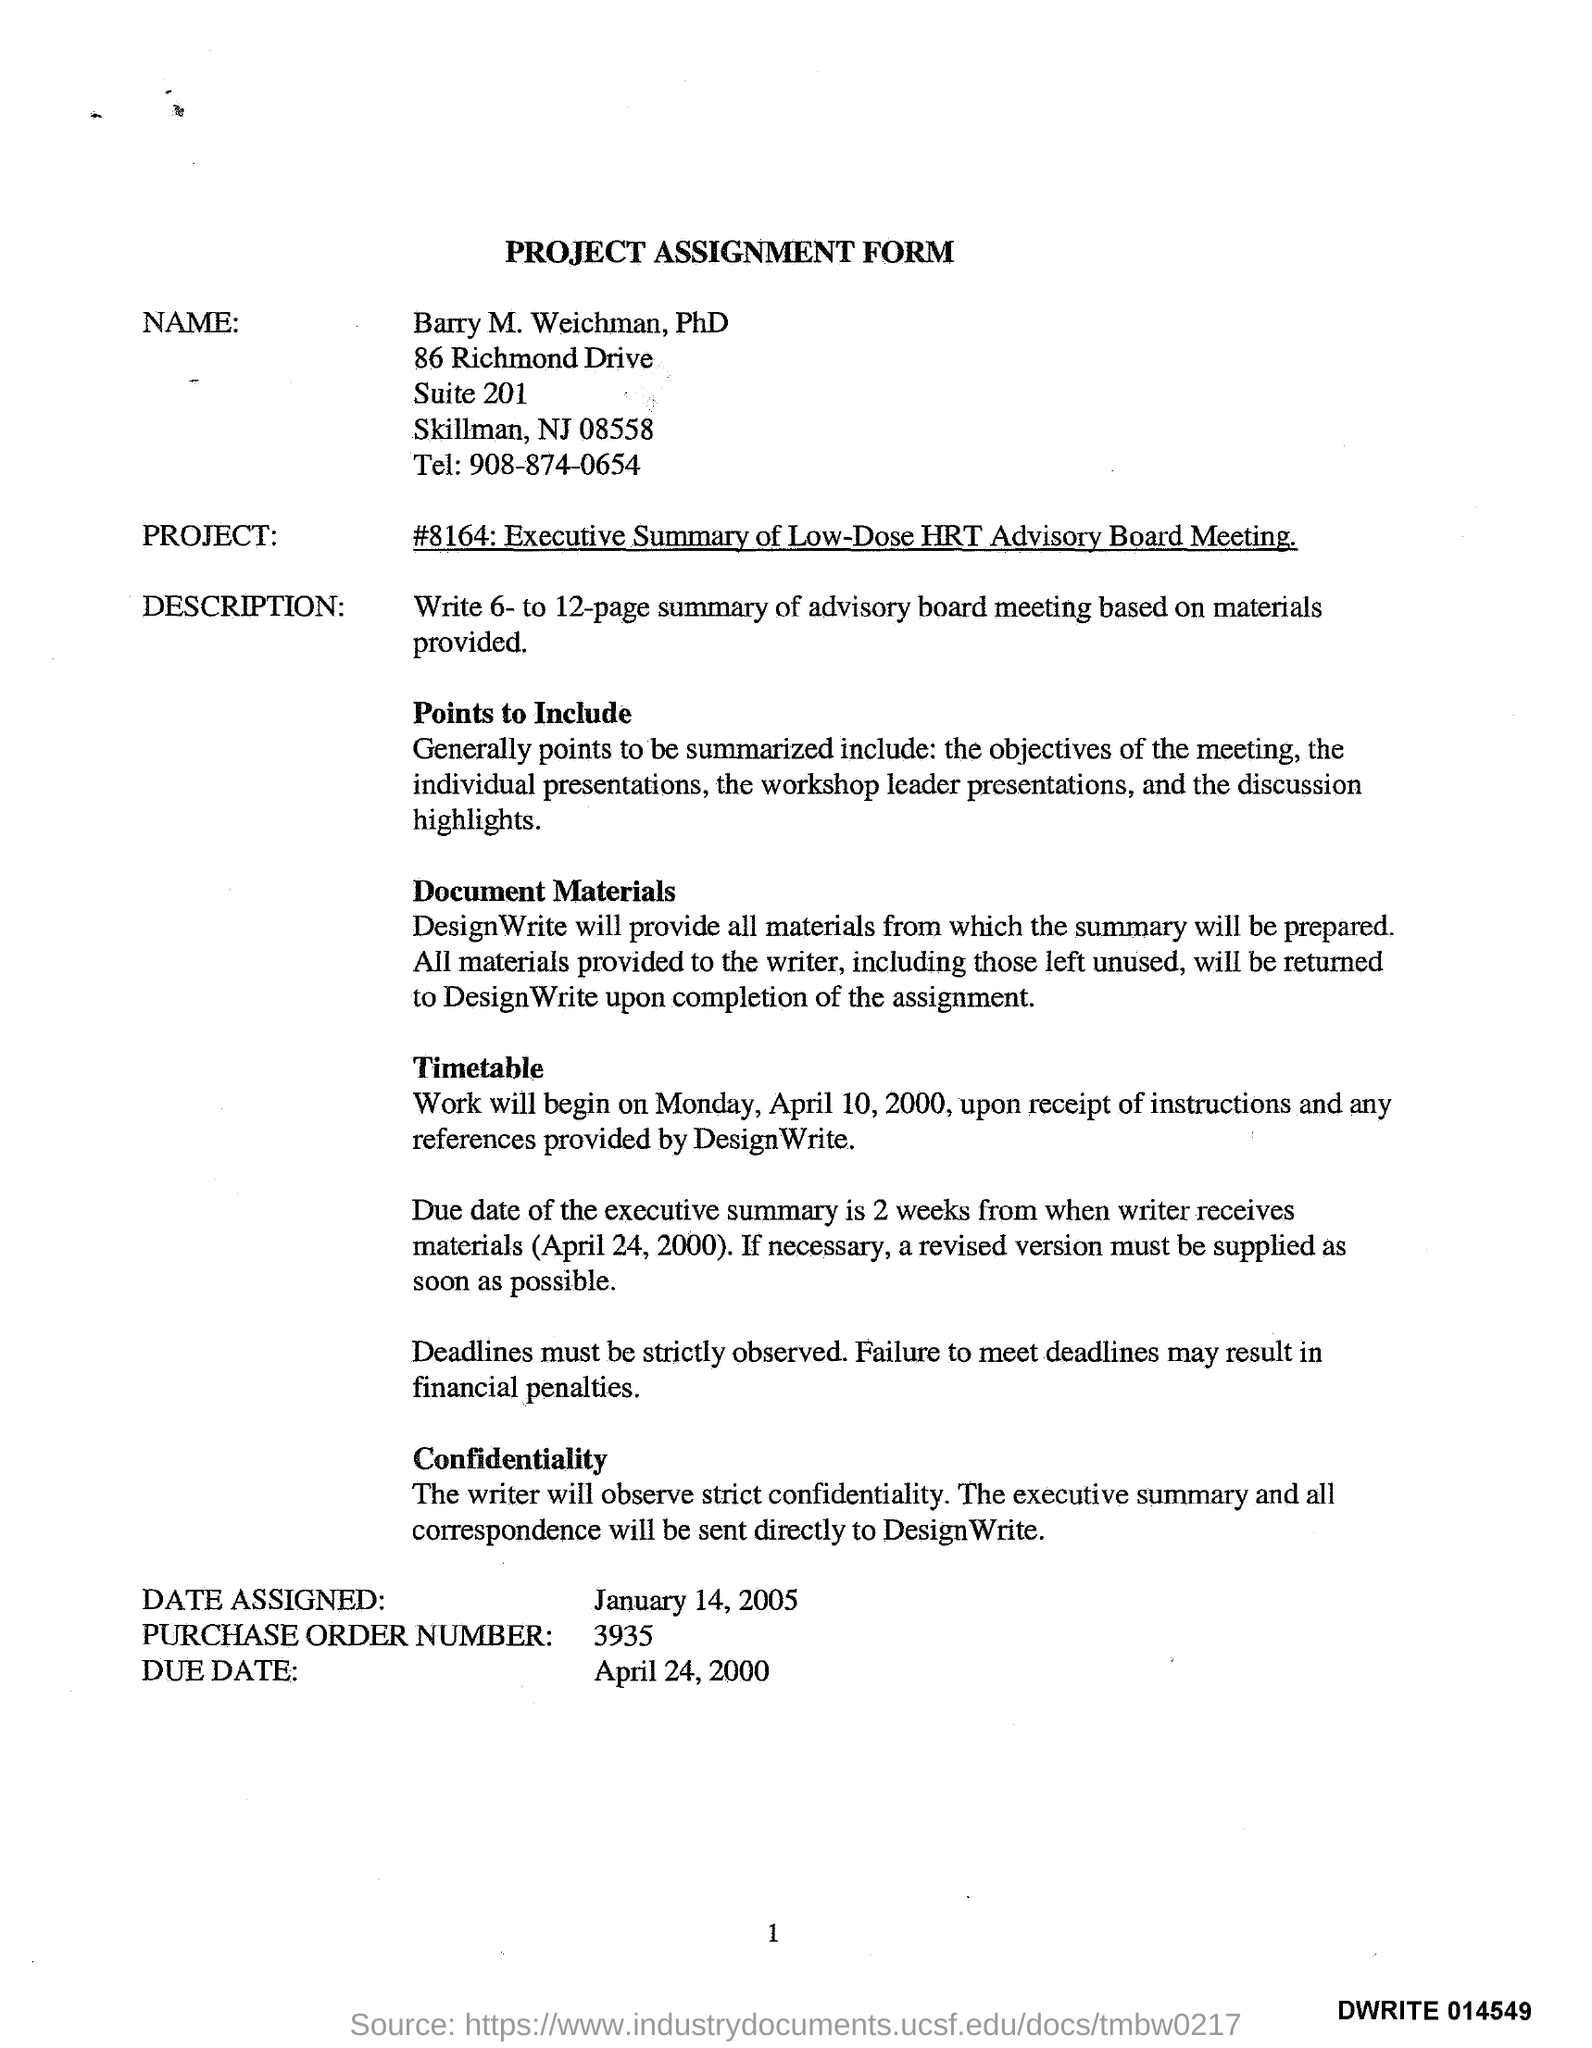What is the Name on the Form?
Give a very brief answer. Barry M. Weichman. What is the Title of the Form?
Keep it short and to the point. PROJECT ASSIGNMENT FORM. What is the Tel.?
Offer a very short reply. 908-874-0654. When will the work begin?
Make the answer very short. Monday, April 10, 2000. What is the Date Assigned?
Your response must be concise. January 14, 2005. What is the Purchase Order Number?
Ensure brevity in your answer.  3935. 